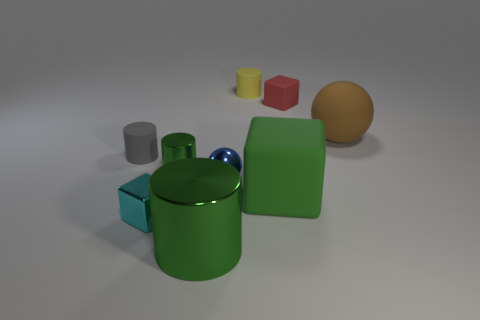Is there anything else that is the same shape as the small red matte object?
Give a very brief answer. Yes. Is the number of small cylinders less than the number of tiny cyan blocks?
Ensure brevity in your answer.  No. What is the big object that is both left of the brown ball and behind the cyan shiny thing made of?
Your answer should be very brief. Rubber. Are there any small gray rubber things that are to the left of the rubber thing that is left of the small cyan thing?
Ensure brevity in your answer.  No. How many objects are tiny gray cubes or large green rubber things?
Your response must be concise. 1. The tiny matte thing that is on the right side of the tiny green metallic thing and left of the small red cube has what shape?
Keep it short and to the point. Cylinder. Does the tiny block that is in front of the big sphere have the same material as the brown ball?
Your response must be concise. No. What number of things are rubber cubes or objects in front of the red rubber thing?
Make the answer very short. 8. The large cube that is made of the same material as the big brown sphere is what color?
Provide a short and direct response. Green. What number of other yellow cylinders have the same material as the small yellow cylinder?
Ensure brevity in your answer.  0. 